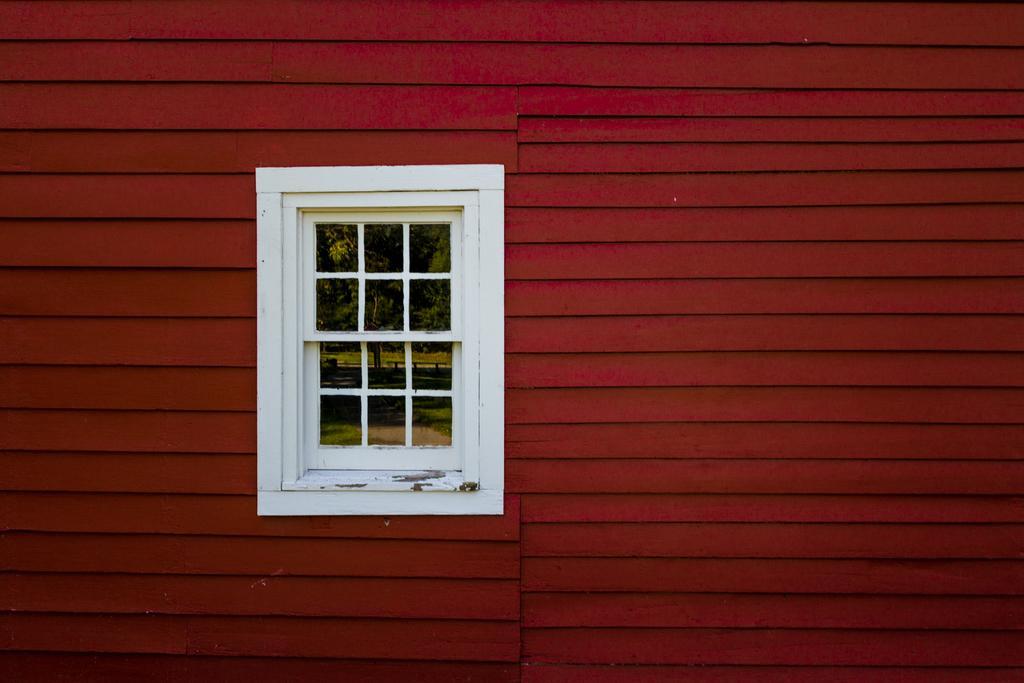Could you give a brief overview of what you see in this image? In this image we can see a red color wall and a white color window, through the window we can see there are some trees. 